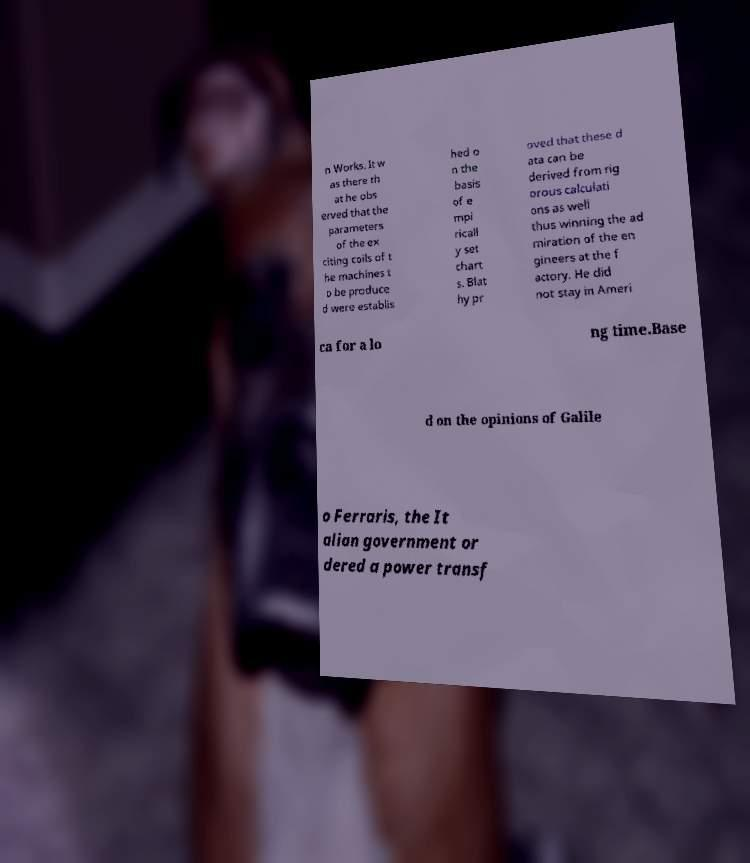There's text embedded in this image that I need extracted. Can you transcribe it verbatim? n Works. It w as there th at he obs erved that the parameters of the ex citing coils of t he machines t o be produce d were establis hed o n the basis of e mpi ricall y set chart s. Blat hy pr oved that these d ata can be derived from rig orous calculati ons as well thus winning the ad miration of the en gineers at the f actory. He did not stay in Ameri ca for a lo ng time.Base d on the opinions of Galile o Ferraris, the It alian government or dered a power transf 